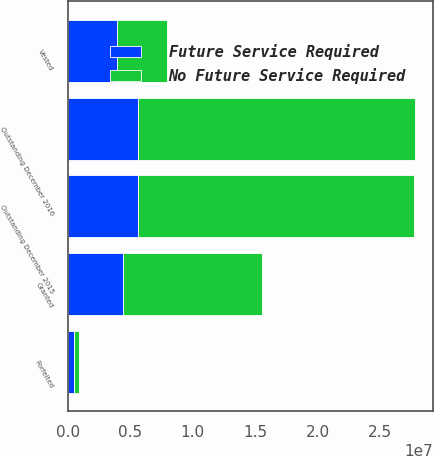<chart> <loc_0><loc_0><loc_500><loc_500><stacked_bar_chart><ecel><fcel>Outstanding December 2015<fcel>Granted<fcel>Forfeited<fcel>Vested<fcel>Outstanding December 2016<nl><fcel>Future Service Required<fcel>5.64916e+06<fcel>4.45236e+06<fcel>501094<fcel>3.97718e+06<fcel>5.62324e+06<nl><fcel>No Future Service Required<fcel>2.20826e+07<fcel>1.10711e+07<fcel>387417<fcel>3.97718e+06<fcel>2.22024e+07<nl></chart> 